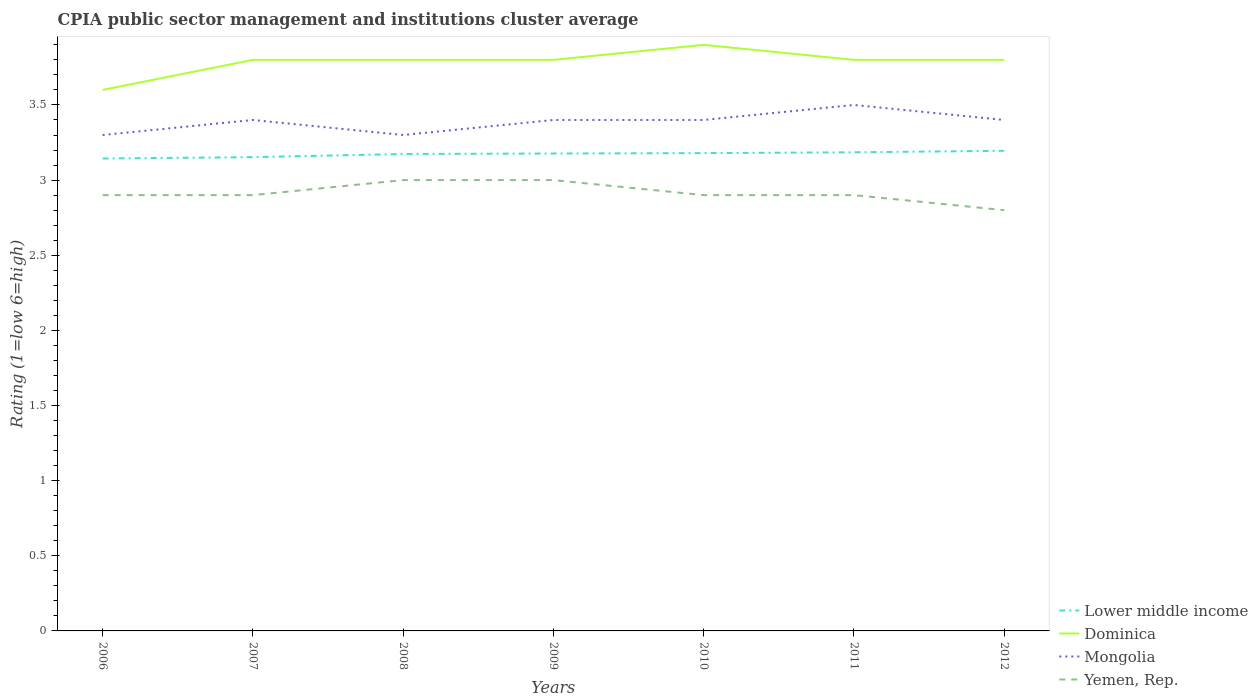How many different coloured lines are there?
Offer a terse response. 4. Across all years, what is the maximum CPIA rating in Yemen, Rep.?
Give a very brief answer. 2.8. In which year was the CPIA rating in Dominica maximum?
Offer a terse response. 2006. What is the difference between the highest and the second highest CPIA rating in Dominica?
Offer a very short reply. 0.3. What is the difference between the highest and the lowest CPIA rating in Mongolia?
Your response must be concise. 5. Is the CPIA rating in Lower middle income strictly greater than the CPIA rating in Dominica over the years?
Your answer should be compact. Yes. What is the difference between two consecutive major ticks on the Y-axis?
Your answer should be very brief. 0.5. Where does the legend appear in the graph?
Offer a very short reply. Bottom right. How many legend labels are there?
Make the answer very short. 4. How are the legend labels stacked?
Provide a succinct answer. Vertical. What is the title of the graph?
Your response must be concise. CPIA public sector management and institutions cluster average. Does "Congo (Democratic)" appear as one of the legend labels in the graph?
Your answer should be very brief. No. What is the Rating (1=low 6=high) of Lower middle income in 2006?
Give a very brief answer. 3.14. What is the Rating (1=low 6=high) in Mongolia in 2006?
Your answer should be very brief. 3.3. What is the Rating (1=low 6=high) in Lower middle income in 2007?
Make the answer very short. 3.15. What is the Rating (1=low 6=high) of Yemen, Rep. in 2007?
Your answer should be very brief. 2.9. What is the Rating (1=low 6=high) of Lower middle income in 2008?
Your answer should be very brief. 3.17. What is the Rating (1=low 6=high) of Dominica in 2008?
Your answer should be very brief. 3.8. What is the Rating (1=low 6=high) of Mongolia in 2008?
Offer a very short reply. 3.3. What is the Rating (1=low 6=high) in Yemen, Rep. in 2008?
Ensure brevity in your answer.  3. What is the Rating (1=low 6=high) in Lower middle income in 2009?
Provide a succinct answer. 3.18. What is the Rating (1=low 6=high) of Dominica in 2009?
Keep it short and to the point. 3.8. What is the Rating (1=low 6=high) in Yemen, Rep. in 2009?
Give a very brief answer. 3. What is the Rating (1=low 6=high) in Lower middle income in 2010?
Make the answer very short. 3.18. What is the Rating (1=low 6=high) of Lower middle income in 2011?
Your response must be concise. 3.19. What is the Rating (1=low 6=high) of Dominica in 2011?
Provide a short and direct response. 3.8. What is the Rating (1=low 6=high) of Mongolia in 2011?
Your response must be concise. 3.5. What is the Rating (1=low 6=high) of Yemen, Rep. in 2011?
Offer a very short reply. 2.9. What is the Rating (1=low 6=high) in Lower middle income in 2012?
Your response must be concise. 3.19. What is the Rating (1=low 6=high) of Yemen, Rep. in 2012?
Make the answer very short. 2.8. Across all years, what is the maximum Rating (1=low 6=high) of Lower middle income?
Your answer should be compact. 3.19. Across all years, what is the maximum Rating (1=low 6=high) of Yemen, Rep.?
Your answer should be very brief. 3. Across all years, what is the minimum Rating (1=low 6=high) in Lower middle income?
Provide a succinct answer. 3.14. Across all years, what is the minimum Rating (1=low 6=high) of Dominica?
Provide a succinct answer. 3.6. Across all years, what is the minimum Rating (1=low 6=high) in Mongolia?
Your answer should be very brief. 3.3. What is the total Rating (1=low 6=high) in Lower middle income in the graph?
Give a very brief answer. 22.21. What is the total Rating (1=low 6=high) in Mongolia in the graph?
Give a very brief answer. 23.7. What is the total Rating (1=low 6=high) in Yemen, Rep. in the graph?
Give a very brief answer. 20.4. What is the difference between the Rating (1=low 6=high) in Lower middle income in 2006 and that in 2007?
Provide a succinct answer. -0.01. What is the difference between the Rating (1=low 6=high) in Mongolia in 2006 and that in 2007?
Your answer should be very brief. -0.1. What is the difference between the Rating (1=low 6=high) in Yemen, Rep. in 2006 and that in 2007?
Your answer should be very brief. 0. What is the difference between the Rating (1=low 6=high) of Lower middle income in 2006 and that in 2008?
Ensure brevity in your answer.  -0.03. What is the difference between the Rating (1=low 6=high) of Mongolia in 2006 and that in 2008?
Keep it short and to the point. 0. What is the difference between the Rating (1=low 6=high) in Yemen, Rep. in 2006 and that in 2008?
Offer a terse response. -0.1. What is the difference between the Rating (1=low 6=high) of Lower middle income in 2006 and that in 2009?
Your response must be concise. -0.03. What is the difference between the Rating (1=low 6=high) in Dominica in 2006 and that in 2009?
Ensure brevity in your answer.  -0.2. What is the difference between the Rating (1=low 6=high) of Yemen, Rep. in 2006 and that in 2009?
Ensure brevity in your answer.  -0.1. What is the difference between the Rating (1=low 6=high) of Lower middle income in 2006 and that in 2010?
Offer a terse response. -0.04. What is the difference between the Rating (1=low 6=high) of Dominica in 2006 and that in 2010?
Ensure brevity in your answer.  -0.3. What is the difference between the Rating (1=low 6=high) in Lower middle income in 2006 and that in 2011?
Provide a succinct answer. -0.04. What is the difference between the Rating (1=low 6=high) in Mongolia in 2006 and that in 2011?
Offer a very short reply. -0.2. What is the difference between the Rating (1=low 6=high) of Lower middle income in 2006 and that in 2012?
Provide a succinct answer. -0.05. What is the difference between the Rating (1=low 6=high) in Dominica in 2006 and that in 2012?
Your answer should be very brief. -0.2. What is the difference between the Rating (1=low 6=high) of Yemen, Rep. in 2006 and that in 2012?
Offer a very short reply. 0.1. What is the difference between the Rating (1=low 6=high) in Lower middle income in 2007 and that in 2008?
Provide a succinct answer. -0.02. What is the difference between the Rating (1=low 6=high) in Mongolia in 2007 and that in 2008?
Provide a short and direct response. 0.1. What is the difference between the Rating (1=low 6=high) in Lower middle income in 2007 and that in 2009?
Ensure brevity in your answer.  -0.02. What is the difference between the Rating (1=low 6=high) in Dominica in 2007 and that in 2009?
Ensure brevity in your answer.  0. What is the difference between the Rating (1=low 6=high) of Lower middle income in 2007 and that in 2010?
Your response must be concise. -0.03. What is the difference between the Rating (1=low 6=high) of Yemen, Rep. in 2007 and that in 2010?
Your response must be concise. 0. What is the difference between the Rating (1=low 6=high) of Lower middle income in 2007 and that in 2011?
Keep it short and to the point. -0.03. What is the difference between the Rating (1=low 6=high) of Dominica in 2007 and that in 2011?
Provide a short and direct response. 0. What is the difference between the Rating (1=low 6=high) of Mongolia in 2007 and that in 2011?
Your response must be concise. -0.1. What is the difference between the Rating (1=low 6=high) of Yemen, Rep. in 2007 and that in 2011?
Your answer should be compact. 0. What is the difference between the Rating (1=low 6=high) in Lower middle income in 2007 and that in 2012?
Keep it short and to the point. -0.04. What is the difference between the Rating (1=low 6=high) of Dominica in 2007 and that in 2012?
Give a very brief answer. 0. What is the difference between the Rating (1=low 6=high) in Yemen, Rep. in 2007 and that in 2012?
Provide a short and direct response. 0.1. What is the difference between the Rating (1=low 6=high) of Lower middle income in 2008 and that in 2009?
Ensure brevity in your answer.  -0. What is the difference between the Rating (1=low 6=high) of Dominica in 2008 and that in 2009?
Provide a short and direct response. 0. What is the difference between the Rating (1=low 6=high) in Yemen, Rep. in 2008 and that in 2009?
Your response must be concise. 0. What is the difference between the Rating (1=low 6=high) in Lower middle income in 2008 and that in 2010?
Your response must be concise. -0.01. What is the difference between the Rating (1=low 6=high) in Mongolia in 2008 and that in 2010?
Keep it short and to the point. -0.1. What is the difference between the Rating (1=low 6=high) of Yemen, Rep. in 2008 and that in 2010?
Give a very brief answer. 0.1. What is the difference between the Rating (1=low 6=high) in Lower middle income in 2008 and that in 2011?
Make the answer very short. -0.01. What is the difference between the Rating (1=low 6=high) of Dominica in 2008 and that in 2011?
Provide a short and direct response. 0. What is the difference between the Rating (1=low 6=high) in Yemen, Rep. in 2008 and that in 2011?
Give a very brief answer. 0.1. What is the difference between the Rating (1=low 6=high) of Lower middle income in 2008 and that in 2012?
Offer a terse response. -0.02. What is the difference between the Rating (1=low 6=high) in Dominica in 2008 and that in 2012?
Your answer should be very brief. 0. What is the difference between the Rating (1=low 6=high) in Mongolia in 2008 and that in 2012?
Provide a short and direct response. -0.1. What is the difference between the Rating (1=low 6=high) in Lower middle income in 2009 and that in 2010?
Your answer should be compact. -0. What is the difference between the Rating (1=low 6=high) in Mongolia in 2009 and that in 2010?
Make the answer very short. 0. What is the difference between the Rating (1=low 6=high) in Lower middle income in 2009 and that in 2011?
Offer a very short reply. -0.01. What is the difference between the Rating (1=low 6=high) of Dominica in 2009 and that in 2011?
Your answer should be compact. 0. What is the difference between the Rating (1=low 6=high) of Yemen, Rep. in 2009 and that in 2011?
Offer a very short reply. 0.1. What is the difference between the Rating (1=low 6=high) of Lower middle income in 2009 and that in 2012?
Keep it short and to the point. -0.02. What is the difference between the Rating (1=low 6=high) in Mongolia in 2009 and that in 2012?
Offer a terse response. 0. What is the difference between the Rating (1=low 6=high) of Yemen, Rep. in 2009 and that in 2012?
Provide a succinct answer. 0.2. What is the difference between the Rating (1=low 6=high) in Lower middle income in 2010 and that in 2011?
Offer a terse response. -0.01. What is the difference between the Rating (1=low 6=high) of Dominica in 2010 and that in 2011?
Offer a very short reply. 0.1. What is the difference between the Rating (1=low 6=high) in Lower middle income in 2010 and that in 2012?
Ensure brevity in your answer.  -0.02. What is the difference between the Rating (1=low 6=high) in Lower middle income in 2011 and that in 2012?
Keep it short and to the point. -0.01. What is the difference between the Rating (1=low 6=high) in Mongolia in 2011 and that in 2012?
Your response must be concise. 0.1. What is the difference between the Rating (1=low 6=high) of Yemen, Rep. in 2011 and that in 2012?
Ensure brevity in your answer.  0.1. What is the difference between the Rating (1=low 6=high) in Lower middle income in 2006 and the Rating (1=low 6=high) in Dominica in 2007?
Make the answer very short. -0.66. What is the difference between the Rating (1=low 6=high) in Lower middle income in 2006 and the Rating (1=low 6=high) in Mongolia in 2007?
Ensure brevity in your answer.  -0.26. What is the difference between the Rating (1=low 6=high) in Lower middle income in 2006 and the Rating (1=low 6=high) in Yemen, Rep. in 2007?
Offer a terse response. 0.24. What is the difference between the Rating (1=low 6=high) in Dominica in 2006 and the Rating (1=low 6=high) in Yemen, Rep. in 2007?
Offer a terse response. 0.7. What is the difference between the Rating (1=low 6=high) in Lower middle income in 2006 and the Rating (1=low 6=high) in Dominica in 2008?
Your response must be concise. -0.66. What is the difference between the Rating (1=low 6=high) of Lower middle income in 2006 and the Rating (1=low 6=high) of Mongolia in 2008?
Ensure brevity in your answer.  -0.16. What is the difference between the Rating (1=low 6=high) in Lower middle income in 2006 and the Rating (1=low 6=high) in Yemen, Rep. in 2008?
Your answer should be very brief. 0.14. What is the difference between the Rating (1=low 6=high) in Dominica in 2006 and the Rating (1=low 6=high) in Mongolia in 2008?
Keep it short and to the point. 0.3. What is the difference between the Rating (1=low 6=high) of Dominica in 2006 and the Rating (1=low 6=high) of Yemen, Rep. in 2008?
Offer a terse response. 0.6. What is the difference between the Rating (1=low 6=high) in Lower middle income in 2006 and the Rating (1=low 6=high) in Dominica in 2009?
Your response must be concise. -0.66. What is the difference between the Rating (1=low 6=high) in Lower middle income in 2006 and the Rating (1=low 6=high) in Mongolia in 2009?
Provide a succinct answer. -0.26. What is the difference between the Rating (1=low 6=high) in Lower middle income in 2006 and the Rating (1=low 6=high) in Yemen, Rep. in 2009?
Your answer should be compact. 0.14. What is the difference between the Rating (1=low 6=high) in Dominica in 2006 and the Rating (1=low 6=high) in Mongolia in 2009?
Provide a short and direct response. 0.2. What is the difference between the Rating (1=low 6=high) in Lower middle income in 2006 and the Rating (1=low 6=high) in Dominica in 2010?
Offer a very short reply. -0.76. What is the difference between the Rating (1=low 6=high) of Lower middle income in 2006 and the Rating (1=low 6=high) of Mongolia in 2010?
Make the answer very short. -0.26. What is the difference between the Rating (1=low 6=high) of Lower middle income in 2006 and the Rating (1=low 6=high) of Yemen, Rep. in 2010?
Provide a short and direct response. 0.24. What is the difference between the Rating (1=low 6=high) in Lower middle income in 2006 and the Rating (1=low 6=high) in Dominica in 2011?
Offer a terse response. -0.66. What is the difference between the Rating (1=low 6=high) in Lower middle income in 2006 and the Rating (1=low 6=high) in Mongolia in 2011?
Provide a short and direct response. -0.36. What is the difference between the Rating (1=low 6=high) of Lower middle income in 2006 and the Rating (1=low 6=high) of Yemen, Rep. in 2011?
Offer a terse response. 0.24. What is the difference between the Rating (1=low 6=high) of Dominica in 2006 and the Rating (1=low 6=high) of Yemen, Rep. in 2011?
Provide a short and direct response. 0.7. What is the difference between the Rating (1=low 6=high) in Mongolia in 2006 and the Rating (1=low 6=high) in Yemen, Rep. in 2011?
Offer a terse response. 0.4. What is the difference between the Rating (1=low 6=high) in Lower middle income in 2006 and the Rating (1=low 6=high) in Dominica in 2012?
Give a very brief answer. -0.66. What is the difference between the Rating (1=low 6=high) of Lower middle income in 2006 and the Rating (1=low 6=high) of Mongolia in 2012?
Offer a very short reply. -0.26. What is the difference between the Rating (1=low 6=high) in Lower middle income in 2006 and the Rating (1=low 6=high) in Yemen, Rep. in 2012?
Your response must be concise. 0.34. What is the difference between the Rating (1=low 6=high) in Dominica in 2006 and the Rating (1=low 6=high) in Mongolia in 2012?
Ensure brevity in your answer.  0.2. What is the difference between the Rating (1=low 6=high) in Dominica in 2006 and the Rating (1=low 6=high) in Yemen, Rep. in 2012?
Provide a short and direct response. 0.8. What is the difference between the Rating (1=low 6=high) of Lower middle income in 2007 and the Rating (1=low 6=high) of Dominica in 2008?
Provide a succinct answer. -0.65. What is the difference between the Rating (1=low 6=high) of Lower middle income in 2007 and the Rating (1=low 6=high) of Mongolia in 2008?
Ensure brevity in your answer.  -0.15. What is the difference between the Rating (1=low 6=high) in Lower middle income in 2007 and the Rating (1=low 6=high) in Yemen, Rep. in 2008?
Your response must be concise. 0.15. What is the difference between the Rating (1=low 6=high) of Mongolia in 2007 and the Rating (1=low 6=high) of Yemen, Rep. in 2008?
Give a very brief answer. 0.4. What is the difference between the Rating (1=low 6=high) in Lower middle income in 2007 and the Rating (1=low 6=high) in Dominica in 2009?
Your answer should be compact. -0.65. What is the difference between the Rating (1=low 6=high) in Lower middle income in 2007 and the Rating (1=low 6=high) in Mongolia in 2009?
Offer a terse response. -0.25. What is the difference between the Rating (1=low 6=high) in Lower middle income in 2007 and the Rating (1=low 6=high) in Yemen, Rep. in 2009?
Your answer should be very brief. 0.15. What is the difference between the Rating (1=low 6=high) of Dominica in 2007 and the Rating (1=low 6=high) of Yemen, Rep. in 2009?
Give a very brief answer. 0.8. What is the difference between the Rating (1=low 6=high) of Mongolia in 2007 and the Rating (1=low 6=high) of Yemen, Rep. in 2009?
Your answer should be compact. 0.4. What is the difference between the Rating (1=low 6=high) in Lower middle income in 2007 and the Rating (1=low 6=high) in Dominica in 2010?
Make the answer very short. -0.75. What is the difference between the Rating (1=low 6=high) in Lower middle income in 2007 and the Rating (1=low 6=high) in Mongolia in 2010?
Offer a terse response. -0.25. What is the difference between the Rating (1=low 6=high) in Lower middle income in 2007 and the Rating (1=low 6=high) in Yemen, Rep. in 2010?
Provide a succinct answer. 0.25. What is the difference between the Rating (1=low 6=high) of Dominica in 2007 and the Rating (1=low 6=high) of Mongolia in 2010?
Your answer should be very brief. 0.4. What is the difference between the Rating (1=low 6=high) of Dominica in 2007 and the Rating (1=low 6=high) of Yemen, Rep. in 2010?
Your answer should be compact. 0.9. What is the difference between the Rating (1=low 6=high) of Lower middle income in 2007 and the Rating (1=low 6=high) of Dominica in 2011?
Make the answer very short. -0.65. What is the difference between the Rating (1=low 6=high) of Lower middle income in 2007 and the Rating (1=low 6=high) of Mongolia in 2011?
Your answer should be compact. -0.35. What is the difference between the Rating (1=low 6=high) in Lower middle income in 2007 and the Rating (1=low 6=high) in Yemen, Rep. in 2011?
Offer a terse response. 0.25. What is the difference between the Rating (1=low 6=high) in Dominica in 2007 and the Rating (1=low 6=high) in Mongolia in 2011?
Your answer should be compact. 0.3. What is the difference between the Rating (1=low 6=high) in Mongolia in 2007 and the Rating (1=low 6=high) in Yemen, Rep. in 2011?
Ensure brevity in your answer.  0.5. What is the difference between the Rating (1=low 6=high) of Lower middle income in 2007 and the Rating (1=low 6=high) of Dominica in 2012?
Your answer should be compact. -0.65. What is the difference between the Rating (1=low 6=high) in Lower middle income in 2007 and the Rating (1=low 6=high) in Mongolia in 2012?
Make the answer very short. -0.25. What is the difference between the Rating (1=low 6=high) in Lower middle income in 2007 and the Rating (1=low 6=high) in Yemen, Rep. in 2012?
Your answer should be compact. 0.35. What is the difference between the Rating (1=low 6=high) in Dominica in 2007 and the Rating (1=low 6=high) in Yemen, Rep. in 2012?
Your response must be concise. 1. What is the difference between the Rating (1=low 6=high) in Lower middle income in 2008 and the Rating (1=low 6=high) in Dominica in 2009?
Give a very brief answer. -0.63. What is the difference between the Rating (1=low 6=high) of Lower middle income in 2008 and the Rating (1=low 6=high) of Mongolia in 2009?
Provide a succinct answer. -0.23. What is the difference between the Rating (1=low 6=high) in Lower middle income in 2008 and the Rating (1=low 6=high) in Yemen, Rep. in 2009?
Your response must be concise. 0.17. What is the difference between the Rating (1=low 6=high) of Mongolia in 2008 and the Rating (1=low 6=high) of Yemen, Rep. in 2009?
Offer a terse response. 0.3. What is the difference between the Rating (1=low 6=high) of Lower middle income in 2008 and the Rating (1=low 6=high) of Dominica in 2010?
Your answer should be compact. -0.73. What is the difference between the Rating (1=low 6=high) of Lower middle income in 2008 and the Rating (1=low 6=high) of Mongolia in 2010?
Make the answer very short. -0.23. What is the difference between the Rating (1=low 6=high) in Lower middle income in 2008 and the Rating (1=low 6=high) in Yemen, Rep. in 2010?
Make the answer very short. 0.27. What is the difference between the Rating (1=low 6=high) of Dominica in 2008 and the Rating (1=low 6=high) of Mongolia in 2010?
Make the answer very short. 0.4. What is the difference between the Rating (1=low 6=high) in Dominica in 2008 and the Rating (1=low 6=high) in Yemen, Rep. in 2010?
Your response must be concise. 0.9. What is the difference between the Rating (1=low 6=high) of Mongolia in 2008 and the Rating (1=low 6=high) of Yemen, Rep. in 2010?
Make the answer very short. 0.4. What is the difference between the Rating (1=low 6=high) of Lower middle income in 2008 and the Rating (1=low 6=high) of Dominica in 2011?
Offer a very short reply. -0.63. What is the difference between the Rating (1=low 6=high) in Lower middle income in 2008 and the Rating (1=low 6=high) in Mongolia in 2011?
Offer a terse response. -0.33. What is the difference between the Rating (1=low 6=high) in Lower middle income in 2008 and the Rating (1=low 6=high) in Yemen, Rep. in 2011?
Give a very brief answer. 0.27. What is the difference between the Rating (1=low 6=high) of Mongolia in 2008 and the Rating (1=low 6=high) of Yemen, Rep. in 2011?
Ensure brevity in your answer.  0.4. What is the difference between the Rating (1=low 6=high) in Lower middle income in 2008 and the Rating (1=low 6=high) in Dominica in 2012?
Ensure brevity in your answer.  -0.63. What is the difference between the Rating (1=low 6=high) in Lower middle income in 2008 and the Rating (1=low 6=high) in Mongolia in 2012?
Make the answer very short. -0.23. What is the difference between the Rating (1=low 6=high) in Lower middle income in 2008 and the Rating (1=low 6=high) in Yemen, Rep. in 2012?
Your answer should be compact. 0.37. What is the difference between the Rating (1=low 6=high) in Dominica in 2008 and the Rating (1=low 6=high) in Mongolia in 2012?
Your answer should be compact. 0.4. What is the difference between the Rating (1=low 6=high) of Dominica in 2008 and the Rating (1=low 6=high) of Yemen, Rep. in 2012?
Your response must be concise. 1. What is the difference between the Rating (1=low 6=high) in Mongolia in 2008 and the Rating (1=low 6=high) in Yemen, Rep. in 2012?
Offer a terse response. 0.5. What is the difference between the Rating (1=low 6=high) in Lower middle income in 2009 and the Rating (1=low 6=high) in Dominica in 2010?
Ensure brevity in your answer.  -0.72. What is the difference between the Rating (1=low 6=high) of Lower middle income in 2009 and the Rating (1=low 6=high) of Mongolia in 2010?
Keep it short and to the point. -0.22. What is the difference between the Rating (1=low 6=high) in Lower middle income in 2009 and the Rating (1=low 6=high) in Yemen, Rep. in 2010?
Your answer should be compact. 0.28. What is the difference between the Rating (1=low 6=high) in Dominica in 2009 and the Rating (1=low 6=high) in Mongolia in 2010?
Offer a very short reply. 0.4. What is the difference between the Rating (1=low 6=high) in Dominica in 2009 and the Rating (1=low 6=high) in Yemen, Rep. in 2010?
Give a very brief answer. 0.9. What is the difference between the Rating (1=low 6=high) in Mongolia in 2009 and the Rating (1=low 6=high) in Yemen, Rep. in 2010?
Your answer should be compact. 0.5. What is the difference between the Rating (1=low 6=high) in Lower middle income in 2009 and the Rating (1=low 6=high) in Dominica in 2011?
Provide a succinct answer. -0.62. What is the difference between the Rating (1=low 6=high) of Lower middle income in 2009 and the Rating (1=low 6=high) of Mongolia in 2011?
Keep it short and to the point. -0.32. What is the difference between the Rating (1=low 6=high) in Lower middle income in 2009 and the Rating (1=low 6=high) in Yemen, Rep. in 2011?
Provide a succinct answer. 0.28. What is the difference between the Rating (1=low 6=high) in Dominica in 2009 and the Rating (1=low 6=high) in Mongolia in 2011?
Keep it short and to the point. 0.3. What is the difference between the Rating (1=low 6=high) in Dominica in 2009 and the Rating (1=low 6=high) in Yemen, Rep. in 2011?
Offer a very short reply. 0.9. What is the difference between the Rating (1=low 6=high) in Lower middle income in 2009 and the Rating (1=low 6=high) in Dominica in 2012?
Your response must be concise. -0.62. What is the difference between the Rating (1=low 6=high) of Lower middle income in 2009 and the Rating (1=low 6=high) of Mongolia in 2012?
Give a very brief answer. -0.22. What is the difference between the Rating (1=low 6=high) of Lower middle income in 2009 and the Rating (1=low 6=high) of Yemen, Rep. in 2012?
Make the answer very short. 0.38. What is the difference between the Rating (1=low 6=high) in Dominica in 2009 and the Rating (1=low 6=high) in Yemen, Rep. in 2012?
Your answer should be very brief. 1. What is the difference between the Rating (1=low 6=high) in Mongolia in 2009 and the Rating (1=low 6=high) in Yemen, Rep. in 2012?
Your response must be concise. 0.6. What is the difference between the Rating (1=low 6=high) of Lower middle income in 2010 and the Rating (1=low 6=high) of Dominica in 2011?
Keep it short and to the point. -0.62. What is the difference between the Rating (1=low 6=high) of Lower middle income in 2010 and the Rating (1=low 6=high) of Mongolia in 2011?
Give a very brief answer. -0.32. What is the difference between the Rating (1=low 6=high) of Lower middle income in 2010 and the Rating (1=low 6=high) of Yemen, Rep. in 2011?
Your response must be concise. 0.28. What is the difference between the Rating (1=low 6=high) of Dominica in 2010 and the Rating (1=low 6=high) of Mongolia in 2011?
Provide a succinct answer. 0.4. What is the difference between the Rating (1=low 6=high) of Dominica in 2010 and the Rating (1=low 6=high) of Yemen, Rep. in 2011?
Offer a very short reply. 1. What is the difference between the Rating (1=low 6=high) in Mongolia in 2010 and the Rating (1=low 6=high) in Yemen, Rep. in 2011?
Offer a terse response. 0.5. What is the difference between the Rating (1=low 6=high) of Lower middle income in 2010 and the Rating (1=low 6=high) of Dominica in 2012?
Ensure brevity in your answer.  -0.62. What is the difference between the Rating (1=low 6=high) of Lower middle income in 2010 and the Rating (1=low 6=high) of Mongolia in 2012?
Keep it short and to the point. -0.22. What is the difference between the Rating (1=low 6=high) in Lower middle income in 2010 and the Rating (1=low 6=high) in Yemen, Rep. in 2012?
Make the answer very short. 0.38. What is the difference between the Rating (1=low 6=high) in Dominica in 2010 and the Rating (1=low 6=high) in Mongolia in 2012?
Your answer should be compact. 0.5. What is the difference between the Rating (1=low 6=high) in Dominica in 2010 and the Rating (1=low 6=high) in Yemen, Rep. in 2012?
Make the answer very short. 1.1. What is the difference between the Rating (1=low 6=high) of Mongolia in 2010 and the Rating (1=low 6=high) of Yemen, Rep. in 2012?
Ensure brevity in your answer.  0.6. What is the difference between the Rating (1=low 6=high) in Lower middle income in 2011 and the Rating (1=low 6=high) in Dominica in 2012?
Ensure brevity in your answer.  -0.61. What is the difference between the Rating (1=low 6=high) of Lower middle income in 2011 and the Rating (1=low 6=high) of Mongolia in 2012?
Ensure brevity in your answer.  -0.21. What is the difference between the Rating (1=low 6=high) of Lower middle income in 2011 and the Rating (1=low 6=high) of Yemen, Rep. in 2012?
Provide a short and direct response. 0.39. What is the difference between the Rating (1=low 6=high) in Dominica in 2011 and the Rating (1=low 6=high) in Yemen, Rep. in 2012?
Your answer should be very brief. 1. What is the difference between the Rating (1=low 6=high) in Mongolia in 2011 and the Rating (1=low 6=high) in Yemen, Rep. in 2012?
Your answer should be very brief. 0.7. What is the average Rating (1=low 6=high) in Lower middle income per year?
Your response must be concise. 3.17. What is the average Rating (1=low 6=high) in Dominica per year?
Ensure brevity in your answer.  3.79. What is the average Rating (1=low 6=high) of Mongolia per year?
Offer a terse response. 3.39. What is the average Rating (1=low 6=high) of Yemen, Rep. per year?
Make the answer very short. 2.91. In the year 2006, what is the difference between the Rating (1=low 6=high) of Lower middle income and Rating (1=low 6=high) of Dominica?
Your answer should be compact. -0.46. In the year 2006, what is the difference between the Rating (1=low 6=high) of Lower middle income and Rating (1=low 6=high) of Mongolia?
Offer a terse response. -0.16. In the year 2006, what is the difference between the Rating (1=low 6=high) of Lower middle income and Rating (1=low 6=high) of Yemen, Rep.?
Make the answer very short. 0.24. In the year 2006, what is the difference between the Rating (1=low 6=high) in Dominica and Rating (1=low 6=high) in Mongolia?
Ensure brevity in your answer.  0.3. In the year 2006, what is the difference between the Rating (1=low 6=high) of Mongolia and Rating (1=low 6=high) of Yemen, Rep.?
Provide a succinct answer. 0.4. In the year 2007, what is the difference between the Rating (1=low 6=high) in Lower middle income and Rating (1=low 6=high) in Dominica?
Ensure brevity in your answer.  -0.65. In the year 2007, what is the difference between the Rating (1=low 6=high) of Lower middle income and Rating (1=low 6=high) of Mongolia?
Your response must be concise. -0.25. In the year 2007, what is the difference between the Rating (1=low 6=high) in Lower middle income and Rating (1=low 6=high) in Yemen, Rep.?
Your answer should be compact. 0.25. In the year 2007, what is the difference between the Rating (1=low 6=high) in Dominica and Rating (1=low 6=high) in Mongolia?
Your answer should be very brief. 0.4. In the year 2007, what is the difference between the Rating (1=low 6=high) of Dominica and Rating (1=low 6=high) of Yemen, Rep.?
Offer a very short reply. 0.9. In the year 2007, what is the difference between the Rating (1=low 6=high) of Mongolia and Rating (1=low 6=high) of Yemen, Rep.?
Your response must be concise. 0.5. In the year 2008, what is the difference between the Rating (1=low 6=high) in Lower middle income and Rating (1=low 6=high) in Dominica?
Provide a short and direct response. -0.63. In the year 2008, what is the difference between the Rating (1=low 6=high) in Lower middle income and Rating (1=low 6=high) in Mongolia?
Provide a succinct answer. -0.13. In the year 2008, what is the difference between the Rating (1=low 6=high) in Lower middle income and Rating (1=low 6=high) in Yemen, Rep.?
Make the answer very short. 0.17. In the year 2008, what is the difference between the Rating (1=low 6=high) of Dominica and Rating (1=low 6=high) of Mongolia?
Make the answer very short. 0.5. In the year 2009, what is the difference between the Rating (1=low 6=high) of Lower middle income and Rating (1=low 6=high) of Dominica?
Provide a short and direct response. -0.62. In the year 2009, what is the difference between the Rating (1=low 6=high) of Lower middle income and Rating (1=low 6=high) of Mongolia?
Keep it short and to the point. -0.22. In the year 2009, what is the difference between the Rating (1=low 6=high) of Lower middle income and Rating (1=low 6=high) of Yemen, Rep.?
Offer a very short reply. 0.18. In the year 2009, what is the difference between the Rating (1=low 6=high) in Mongolia and Rating (1=low 6=high) in Yemen, Rep.?
Provide a succinct answer. 0.4. In the year 2010, what is the difference between the Rating (1=low 6=high) in Lower middle income and Rating (1=low 6=high) in Dominica?
Your answer should be very brief. -0.72. In the year 2010, what is the difference between the Rating (1=low 6=high) of Lower middle income and Rating (1=low 6=high) of Mongolia?
Your answer should be very brief. -0.22. In the year 2010, what is the difference between the Rating (1=low 6=high) of Lower middle income and Rating (1=low 6=high) of Yemen, Rep.?
Provide a succinct answer. 0.28. In the year 2011, what is the difference between the Rating (1=low 6=high) of Lower middle income and Rating (1=low 6=high) of Dominica?
Your response must be concise. -0.61. In the year 2011, what is the difference between the Rating (1=low 6=high) of Lower middle income and Rating (1=low 6=high) of Mongolia?
Ensure brevity in your answer.  -0.32. In the year 2011, what is the difference between the Rating (1=low 6=high) in Lower middle income and Rating (1=low 6=high) in Yemen, Rep.?
Keep it short and to the point. 0.28. In the year 2011, what is the difference between the Rating (1=low 6=high) of Dominica and Rating (1=low 6=high) of Yemen, Rep.?
Provide a succinct answer. 0.9. In the year 2012, what is the difference between the Rating (1=low 6=high) in Lower middle income and Rating (1=low 6=high) in Dominica?
Offer a very short reply. -0.6. In the year 2012, what is the difference between the Rating (1=low 6=high) in Lower middle income and Rating (1=low 6=high) in Mongolia?
Offer a very short reply. -0.2. In the year 2012, what is the difference between the Rating (1=low 6=high) of Lower middle income and Rating (1=low 6=high) of Yemen, Rep.?
Offer a very short reply. 0.4. In the year 2012, what is the difference between the Rating (1=low 6=high) in Dominica and Rating (1=low 6=high) in Yemen, Rep.?
Your response must be concise. 1. In the year 2012, what is the difference between the Rating (1=low 6=high) of Mongolia and Rating (1=low 6=high) of Yemen, Rep.?
Your answer should be compact. 0.6. What is the ratio of the Rating (1=low 6=high) of Lower middle income in 2006 to that in 2007?
Your answer should be compact. 1. What is the ratio of the Rating (1=low 6=high) of Dominica in 2006 to that in 2007?
Your response must be concise. 0.95. What is the ratio of the Rating (1=low 6=high) of Mongolia in 2006 to that in 2007?
Your response must be concise. 0.97. What is the ratio of the Rating (1=low 6=high) of Yemen, Rep. in 2006 to that in 2007?
Your answer should be compact. 1. What is the ratio of the Rating (1=low 6=high) in Lower middle income in 2006 to that in 2008?
Keep it short and to the point. 0.99. What is the ratio of the Rating (1=low 6=high) in Yemen, Rep. in 2006 to that in 2008?
Provide a succinct answer. 0.97. What is the ratio of the Rating (1=low 6=high) in Lower middle income in 2006 to that in 2009?
Offer a terse response. 0.99. What is the ratio of the Rating (1=low 6=high) of Mongolia in 2006 to that in 2009?
Provide a succinct answer. 0.97. What is the ratio of the Rating (1=low 6=high) of Yemen, Rep. in 2006 to that in 2009?
Ensure brevity in your answer.  0.97. What is the ratio of the Rating (1=low 6=high) of Lower middle income in 2006 to that in 2010?
Your response must be concise. 0.99. What is the ratio of the Rating (1=low 6=high) in Dominica in 2006 to that in 2010?
Make the answer very short. 0.92. What is the ratio of the Rating (1=low 6=high) of Mongolia in 2006 to that in 2010?
Ensure brevity in your answer.  0.97. What is the ratio of the Rating (1=low 6=high) in Lower middle income in 2006 to that in 2011?
Make the answer very short. 0.99. What is the ratio of the Rating (1=low 6=high) in Dominica in 2006 to that in 2011?
Your answer should be compact. 0.95. What is the ratio of the Rating (1=low 6=high) of Mongolia in 2006 to that in 2011?
Make the answer very short. 0.94. What is the ratio of the Rating (1=low 6=high) of Yemen, Rep. in 2006 to that in 2011?
Your answer should be very brief. 1. What is the ratio of the Rating (1=low 6=high) of Lower middle income in 2006 to that in 2012?
Offer a very short reply. 0.98. What is the ratio of the Rating (1=low 6=high) in Dominica in 2006 to that in 2012?
Your response must be concise. 0.95. What is the ratio of the Rating (1=low 6=high) in Mongolia in 2006 to that in 2012?
Offer a terse response. 0.97. What is the ratio of the Rating (1=low 6=high) of Yemen, Rep. in 2006 to that in 2012?
Keep it short and to the point. 1.04. What is the ratio of the Rating (1=low 6=high) in Mongolia in 2007 to that in 2008?
Your answer should be compact. 1.03. What is the ratio of the Rating (1=low 6=high) of Yemen, Rep. in 2007 to that in 2008?
Make the answer very short. 0.97. What is the ratio of the Rating (1=low 6=high) of Mongolia in 2007 to that in 2009?
Make the answer very short. 1. What is the ratio of the Rating (1=low 6=high) of Yemen, Rep. in 2007 to that in 2009?
Your answer should be very brief. 0.97. What is the ratio of the Rating (1=low 6=high) of Dominica in 2007 to that in 2010?
Provide a succinct answer. 0.97. What is the ratio of the Rating (1=low 6=high) in Yemen, Rep. in 2007 to that in 2010?
Give a very brief answer. 1. What is the ratio of the Rating (1=low 6=high) of Lower middle income in 2007 to that in 2011?
Ensure brevity in your answer.  0.99. What is the ratio of the Rating (1=low 6=high) in Mongolia in 2007 to that in 2011?
Provide a succinct answer. 0.97. What is the ratio of the Rating (1=low 6=high) in Yemen, Rep. in 2007 to that in 2011?
Provide a succinct answer. 1. What is the ratio of the Rating (1=low 6=high) in Lower middle income in 2007 to that in 2012?
Ensure brevity in your answer.  0.99. What is the ratio of the Rating (1=low 6=high) of Dominica in 2007 to that in 2012?
Your answer should be very brief. 1. What is the ratio of the Rating (1=low 6=high) of Mongolia in 2007 to that in 2012?
Keep it short and to the point. 1. What is the ratio of the Rating (1=low 6=high) of Yemen, Rep. in 2007 to that in 2012?
Provide a short and direct response. 1.04. What is the ratio of the Rating (1=low 6=high) of Lower middle income in 2008 to that in 2009?
Give a very brief answer. 1. What is the ratio of the Rating (1=low 6=high) of Dominica in 2008 to that in 2009?
Provide a short and direct response. 1. What is the ratio of the Rating (1=low 6=high) in Mongolia in 2008 to that in 2009?
Your answer should be compact. 0.97. What is the ratio of the Rating (1=low 6=high) in Dominica in 2008 to that in 2010?
Your answer should be very brief. 0.97. What is the ratio of the Rating (1=low 6=high) of Mongolia in 2008 to that in 2010?
Your response must be concise. 0.97. What is the ratio of the Rating (1=low 6=high) in Yemen, Rep. in 2008 to that in 2010?
Provide a succinct answer. 1.03. What is the ratio of the Rating (1=low 6=high) in Lower middle income in 2008 to that in 2011?
Provide a succinct answer. 1. What is the ratio of the Rating (1=low 6=high) in Dominica in 2008 to that in 2011?
Offer a very short reply. 1. What is the ratio of the Rating (1=low 6=high) in Mongolia in 2008 to that in 2011?
Ensure brevity in your answer.  0.94. What is the ratio of the Rating (1=low 6=high) of Yemen, Rep. in 2008 to that in 2011?
Your answer should be compact. 1.03. What is the ratio of the Rating (1=low 6=high) in Mongolia in 2008 to that in 2012?
Offer a terse response. 0.97. What is the ratio of the Rating (1=low 6=high) in Yemen, Rep. in 2008 to that in 2012?
Provide a short and direct response. 1.07. What is the ratio of the Rating (1=low 6=high) in Dominica in 2009 to that in 2010?
Make the answer very short. 0.97. What is the ratio of the Rating (1=low 6=high) in Mongolia in 2009 to that in 2010?
Provide a succinct answer. 1. What is the ratio of the Rating (1=low 6=high) in Yemen, Rep. in 2009 to that in 2010?
Your response must be concise. 1.03. What is the ratio of the Rating (1=low 6=high) in Mongolia in 2009 to that in 2011?
Keep it short and to the point. 0.97. What is the ratio of the Rating (1=low 6=high) of Yemen, Rep. in 2009 to that in 2011?
Provide a short and direct response. 1.03. What is the ratio of the Rating (1=low 6=high) of Lower middle income in 2009 to that in 2012?
Offer a very short reply. 0.99. What is the ratio of the Rating (1=low 6=high) in Dominica in 2009 to that in 2012?
Keep it short and to the point. 1. What is the ratio of the Rating (1=low 6=high) in Yemen, Rep. in 2009 to that in 2012?
Give a very brief answer. 1.07. What is the ratio of the Rating (1=low 6=high) of Lower middle income in 2010 to that in 2011?
Your answer should be compact. 1. What is the ratio of the Rating (1=low 6=high) of Dominica in 2010 to that in 2011?
Provide a short and direct response. 1.03. What is the ratio of the Rating (1=low 6=high) in Mongolia in 2010 to that in 2011?
Your answer should be compact. 0.97. What is the ratio of the Rating (1=low 6=high) in Dominica in 2010 to that in 2012?
Provide a short and direct response. 1.03. What is the ratio of the Rating (1=low 6=high) in Yemen, Rep. in 2010 to that in 2012?
Your answer should be very brief. 1.04. What is the ratio of the Rating (1=low 6=high) in Mongolia in 2011 to that in 2012?
Offer a very short reply. 1.03. What is the ratio of the Rating (1=low 6=high) of Yemen, Rep. in 2011 to that in 2012?
Your response must be concise. 1.04. What is the difference between the highest and the lowest Rating (1=low 6=high) in Lower middle income?
Your response must be concise. 0.05. What is the difference between the highest and the lowest Rating (1=low 6=high) in Dominica?
Keep it short and to the point. 0.3. What is the difference between the highest and the lowest Rating (1=low 6=high) in Yemen, Rep.?
Provide a succinct answer. 0.2. 